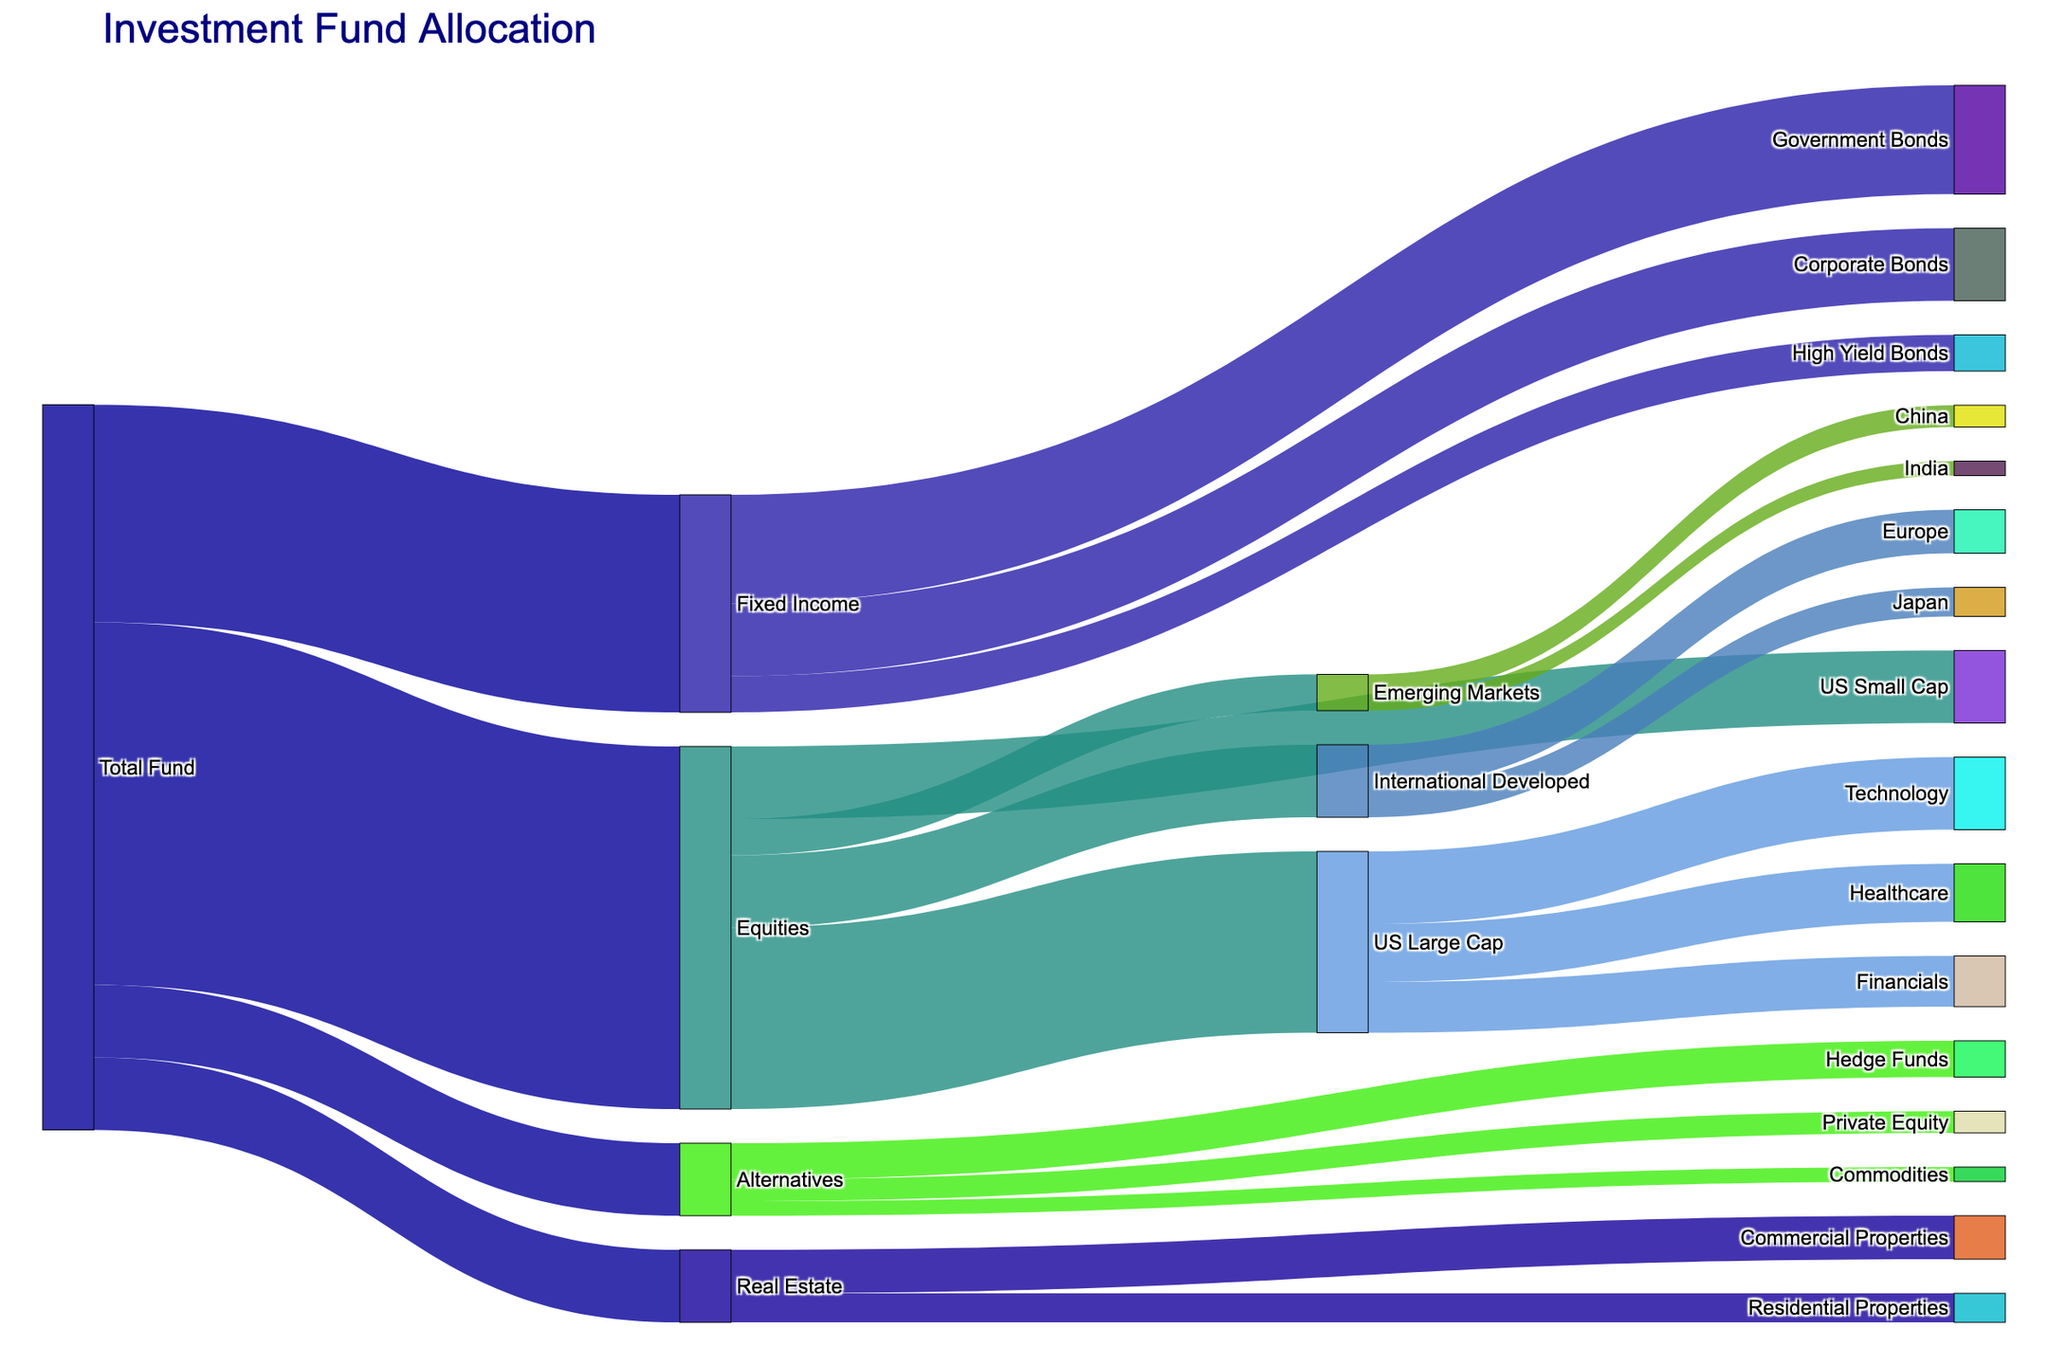- What is the title of the figure? The title is located at the top of the figure. It describes the content of the Sankey Diagram.
Answer: Investment Fund Allocation - How much of the total fund is allocated to Equities? The source "Total Fund" connects to "Equities" with a value of 50.
Answer: 50 - Which sector within US Large Cap receives the most allocation? Within the US Large Cap node, the sector with the highest value is "Technology" with a value of 10.
Answer: Technology - How much is the total allocation for Real Estate? Real Estate is divided into "Commercial Properties" (6) and "Residential Properties" (4). Summing these gives 6 + 4.
Answer: 10 - Compare the allocation between US Large Cap and International Developed classes within Equities. Which has more? US Large Cap has 25, and International Developed has 10. US Large Cap is greater.
Answer: US Large Cap - How many different asset classes are there in the total fund allocation? Asset classes connected directly to "Total Fund" are Equities, Fixed Income, Real Estate, and Alternatives, totaling 4.
Answer: 4 - What percentage of the total fund is allocated to Fixed Income? Fixed Income has 30, and the Total Fund is 100. (30/100)*100 gives 30%.
Answer: 30% - Within Alternatives, how does the allocation to Hedge Funds compare to Private Equity? Hedge Funds have 5 and Private Equity has 3. Hedge Funds have a higher allocation.
Answer: Hedge Funds - What is the total allocation under the Equities section? Equities section includes US Large Cap (25), US Small Cap (10), International Developed (10), and Emerging Markets (5). Summing these, 25 + 10 + 10 + 5 = 50.
Answer: 50 - Which international region receives a higher allocation: Europe or Japan? Europe has 6, and Japan has 4 under International Developed. Europe has a higher allocation.
Answer: Europe 